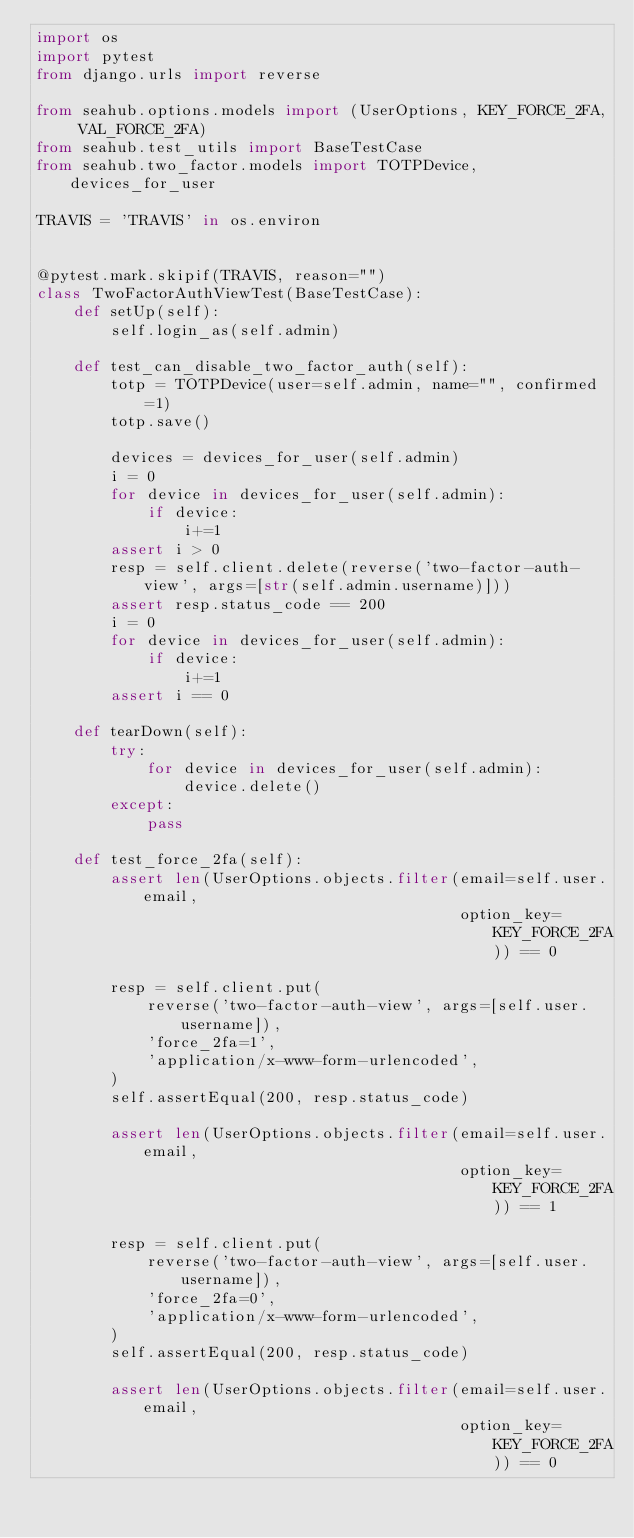<code> <loc_0><loc_0><loc_500><loc_500><_Python_>import os
import pytest
from django.urls import reverse

from seahub.options.models import (UserOptions, KEY_FORCE_2FA, VAL_FORCE_2FA)
from seahub.test_utils import BaseTestCase
from seahub.two_factor.models import TOTPDevice, devices_for_user

TRAVIS = 'TRAVIS' in os.environ


@pytest.mark.skipif(TRAVIS, reason="")
class TwoFactorAuthViewTest(BaseTestCase):
    def setUp(self):
        self.login_as(self.admin)

    def test_can_disable_two_factor_auth(self):
        totp = TOTPDevice(user=self.admin, name="", confirmed=1)
        totp.save()

        devices = devices_for_user(self.admin)
        i = 0
        for device in devices_for_user(self.admin):
            if device:
                i+=1
        assert i > 0
        resp = self.client.delete(reverse('two-factor-auth-view', args=[str(self.admin.username)]))
        assert resp.status_code == 200
        i = 0
        for device in devices_for_user(self.admin):
            if device:
                i+=1
        assert i == 0

    def tearDown(self):
        try:
            for device in devices_for_user(self.admin):
                device.delete()
        except:
            pass

    def test_force_2fa(self):
        assert len(UserOptions.objects.filter(email=self.user.email,
                                              option_key=KEY_FORCE_2FA)) == 0

        resp = self.client.put(
            reverse('two-factor-auth-view', args=[self.user.username]),
            'force_2fa=1',
            'application/x-www-form-urlencoded',
        )
        self.assertEqual(200, resp.status_code)

        assert len(UserOptions.objects.filter(email=self.user.email,
                                              option_key=KEY_FORCE_2FA)) == 1

        resp = self.client.put(
            reverse('two-factor-auth-view', args=[self.user.username]),
            'force_2fa=0',
            'application/x-www-form-urlencoded',
        )
        self.assertEqual(200, resp.status_code)

        assert len(UserOptions.objects.filter(email=self.user.email,
                                              option_key=KEY_FORCE_2FA)) == 0
</code> 